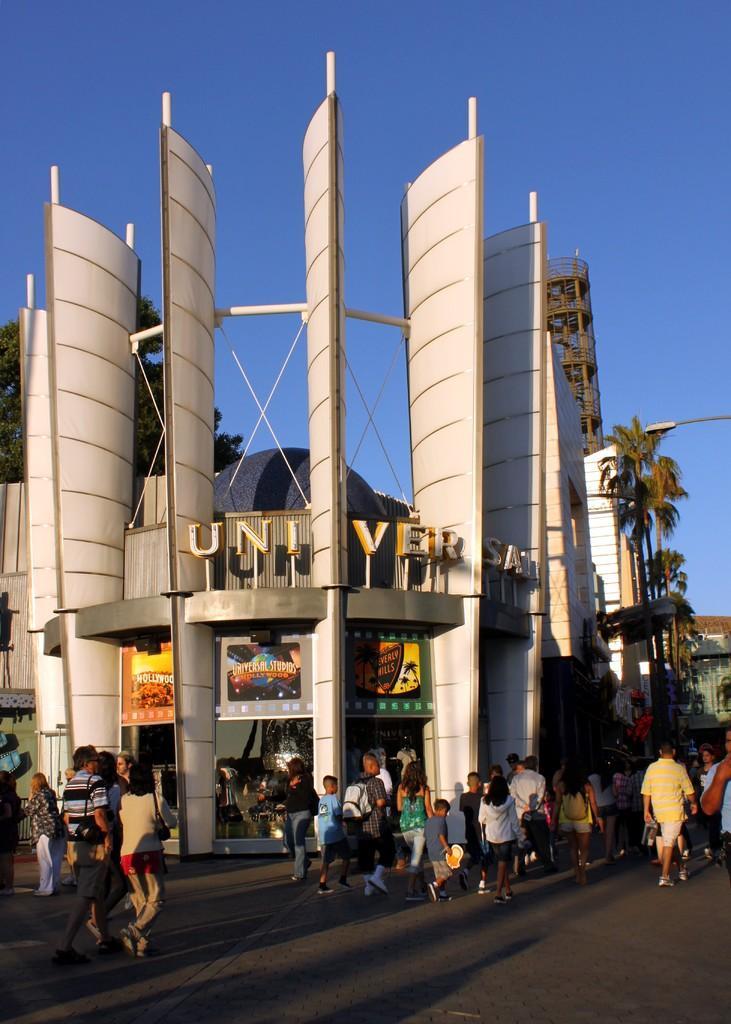Can you describe this image briefly? There are people, posters and text in the foreground area of the image. There are buildings, trees, pole and sky in the background area. 